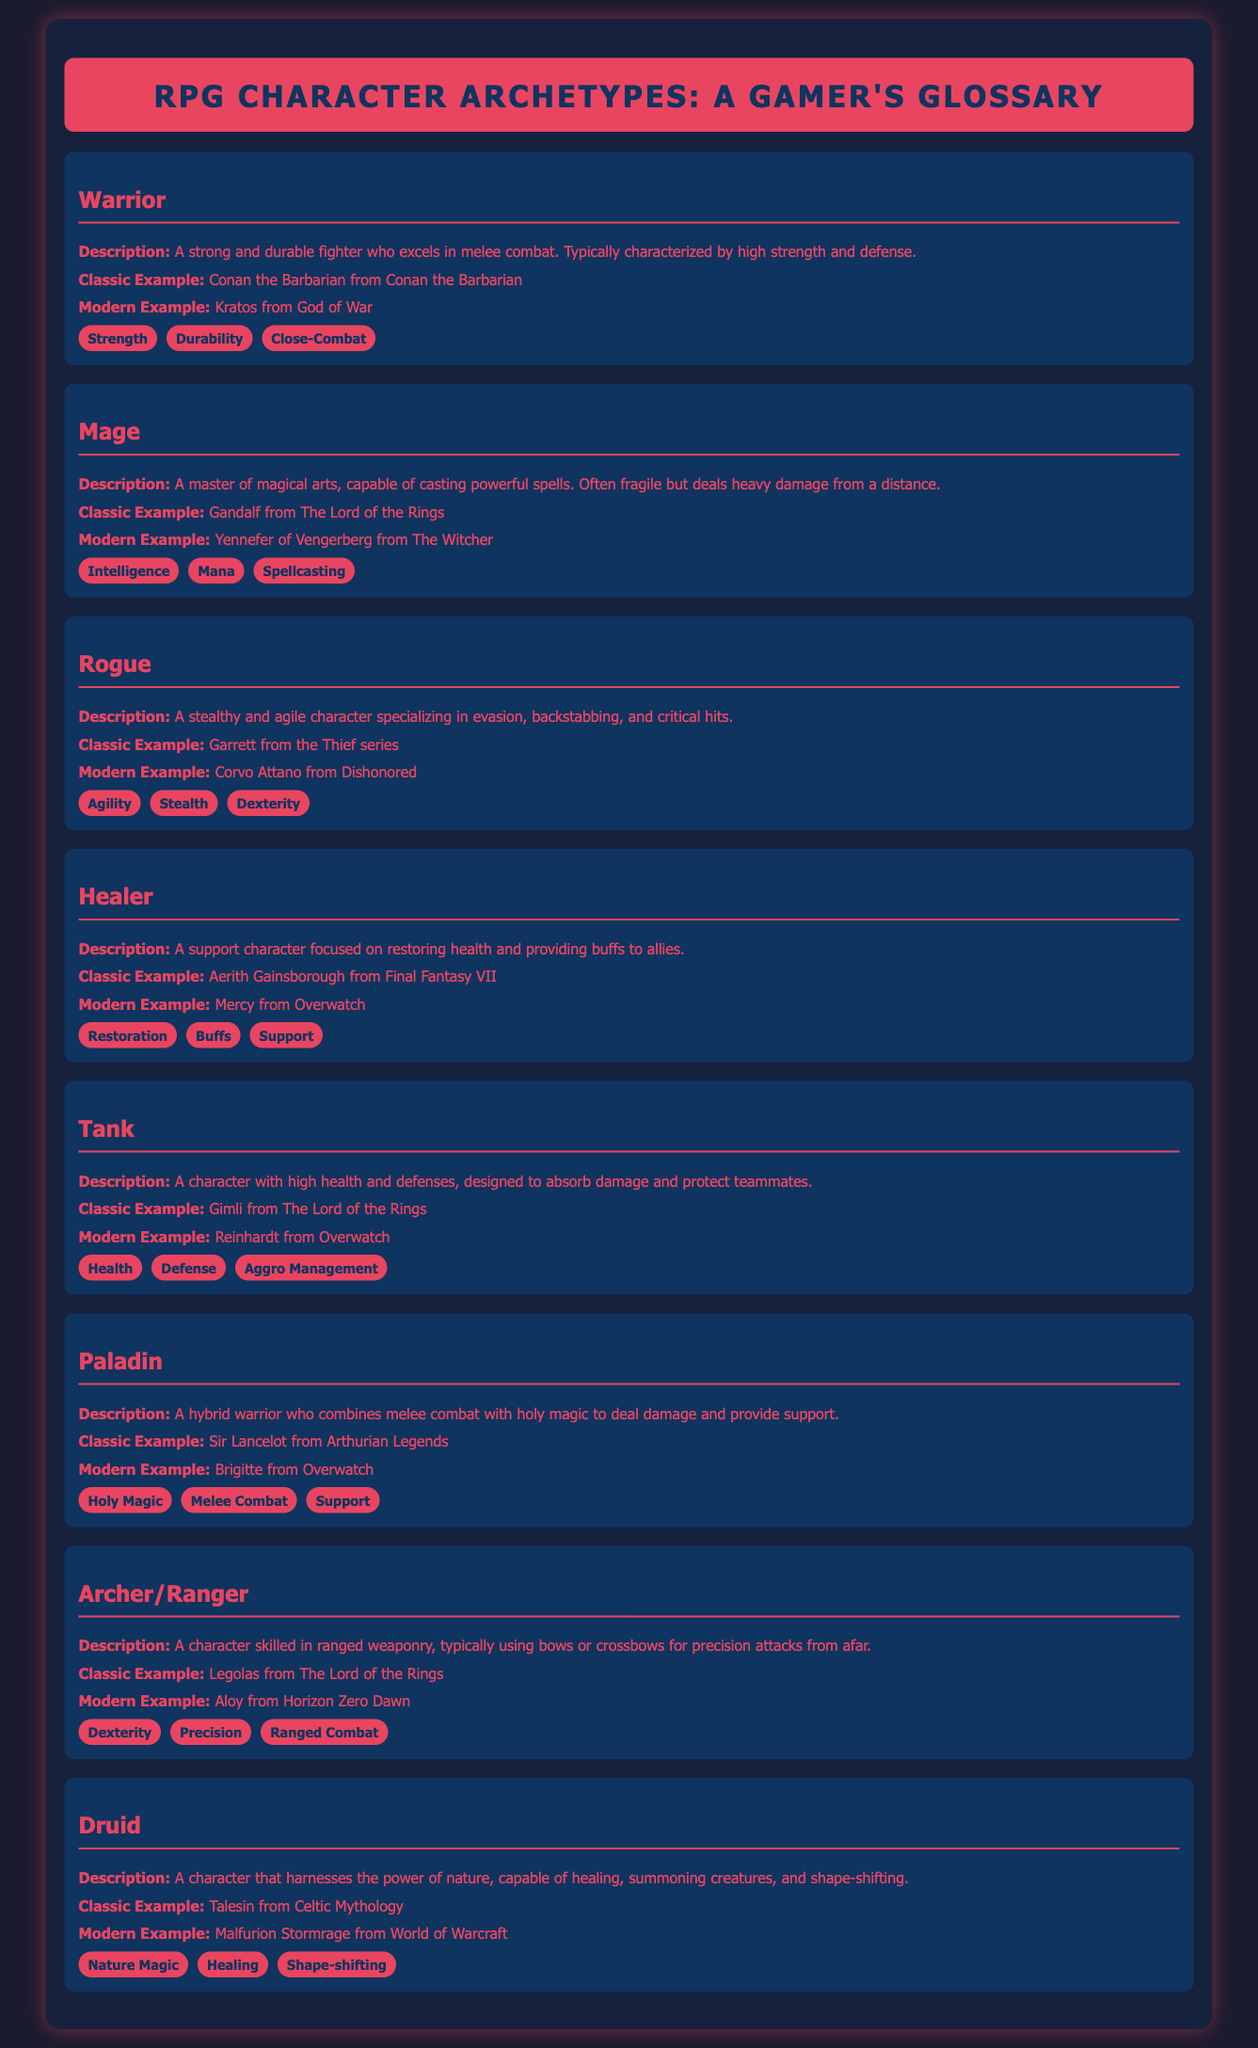What is the description of a Warrior? The description of a Warrior is that it's a strong and durable fighter who excels in melee combat.
Answer: A strong and durable fighter who excels in melee combat Who is the modern example of a Mage? The modern example of a Mage is Yennefer of Vengerberg from The Witcher.
Answer: Yennefer of Vengerberg from The Witcher What traits are associated with a Rogue? The traits associated with a Rogue include Agility, Stealth, and Dexterity.
Answer: Agility, Stealth, Dexterity What is the classic example of a Healer? The classic example of a Healer is Aerith Gainsborough from Final Fantasy VII.
Answer: Aerith Gainsborough from Final Fantasy VII How many main character archetypes are listed in the document? The document lists a total of eight main character archetypes.
Answer: Eight Which archetype combines melee combat with holy magic? The archetype that combines melee combat with holy magic is the Paladin.
Answer: Paladin What is the main focus of a Tank in RPGs? The main focus of a Tank is to absorb damage and protect teammates.
Answer: Absorb damage and protect teammates Which character is the classic example of an Archer/Ranger? The classic example of an Archer/Ranger is Legolas from The Lord of the Rings.
Answer: Legolas from The Lord of the Rings 